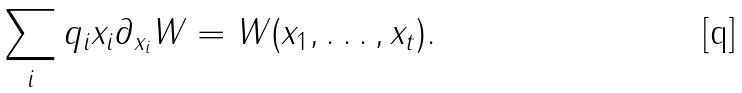Convert formula to latex. <formula><loc_0><loc_0><loc_500><loc_500>\sum _ { i } q _ { i } x _ { i } \partial _ { x _ { i } } W = W ( x _ { 1 } , \dots , x _ { t } ) .</formula> 